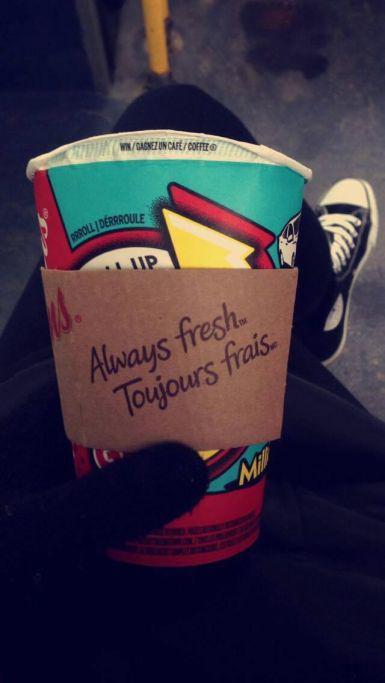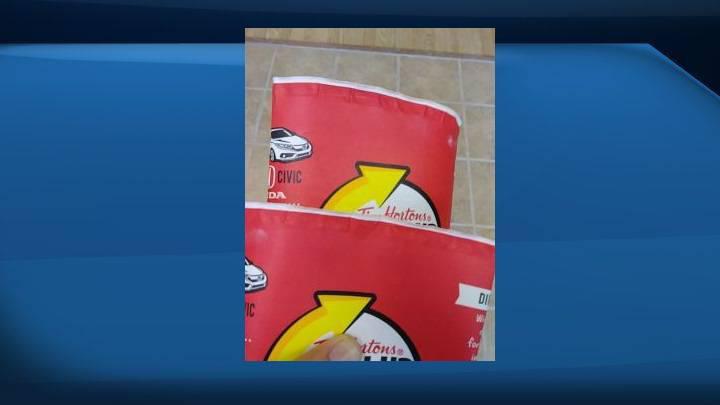The first image is the image on the left, the second image is the image on the right. For the images displayed, is the sentence "There are two red cups with one being held by a hand." factually correct? Answer yes or no. No. 